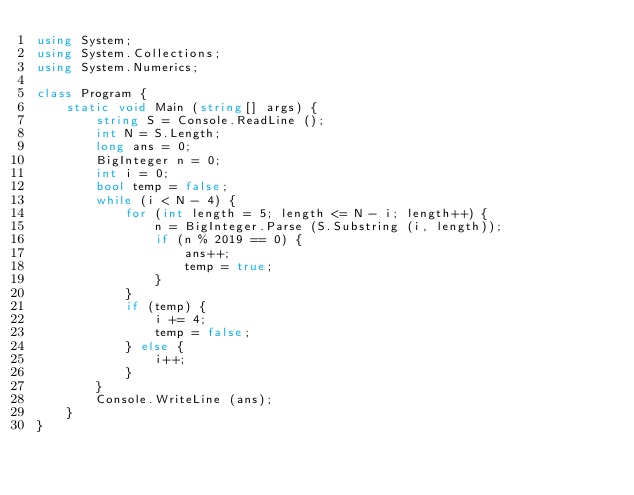Convert code to text. <code><loc_0><loc_0><loc_500><loc_500><_C#_>using System;
using System.Collections;
using System.Numerics;

class Program {
    static void Main (string[] args) {
        string S = Console.ReadLine ();
        int N = S.Length;
        long ans = 0;
        BigInteger n = 0;
        int i = 0;
        bool temp = false;
        while (i < N - 4) {
            for (int length = 5; length <= N - i; length++) {
                n = BigInteger.Parse (S.Substring (i, length));
                if (n % 2019 == 0) {
                    ans++;
                    temp = true;
                }
            }
            if (temp) {
                i += 4;
                temp = false;
            } else {
                i++;
            }
        }
        Console.WriteLine (ans);
    }
}</code> 